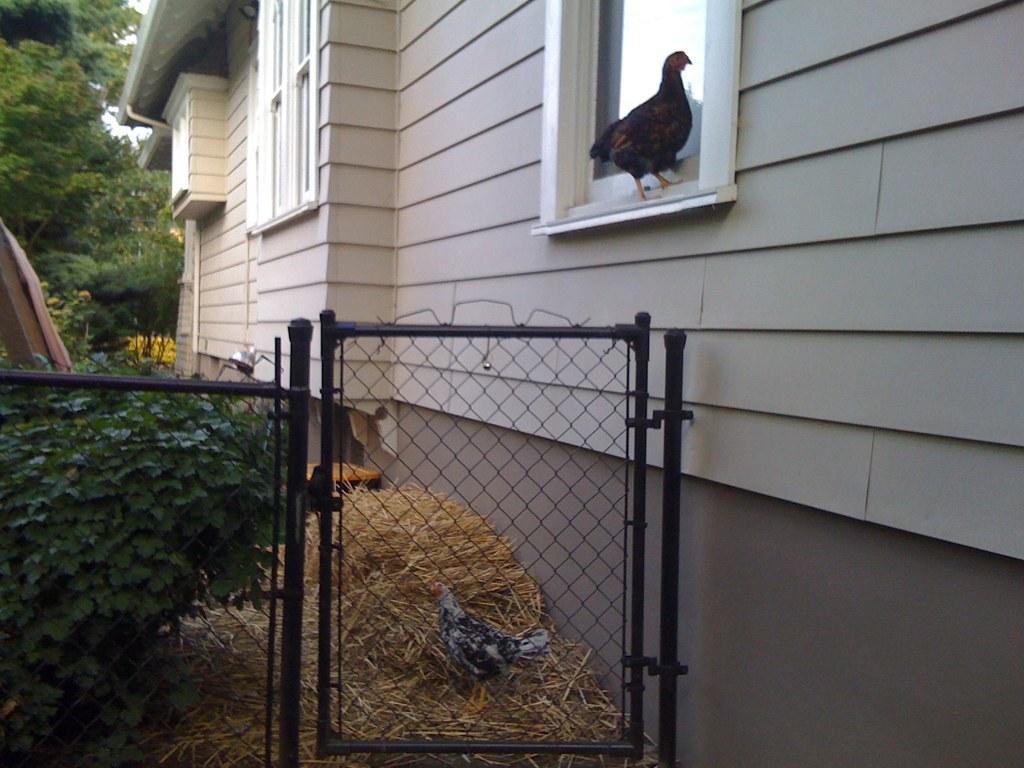How would you summarize this image in a sentence or two? In this picture we can see gate, mesh, hens, box and dried grass. We can see plants, wall, object and windows. In the background of the image we can see trees and sky. 